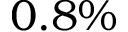<formula> <loc_0><loc_0><loc_500><loc_500>0 . 8 \%</formula> 